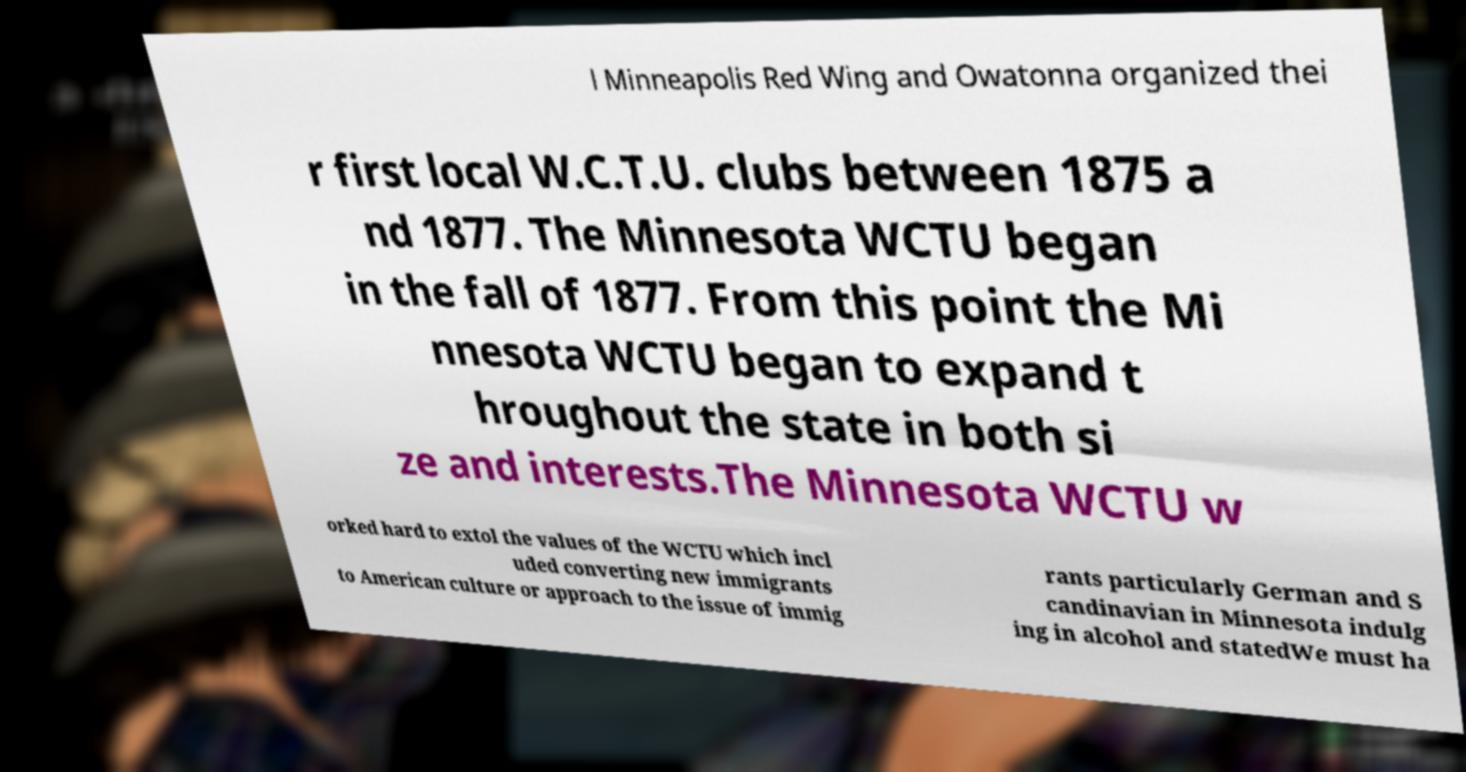I need the written content from this picture converted into text. Can you do that? l Minneapolis Red Wing and Owatonna organized thei r first local W.C.T.U. clubs between 1875 a nd 1877. The Minnesota WCTU began in the fall of 1877. From this point the Mi nnesota WCTU began to expand t hroughout the state in both si ze and interests.The Minnesota WCTU w orked hard to extol the values of the WCTU which incl uded converting new immigrants to American culture or approach to the issue of immig rants particularly German and S candinavian in Minnesota indulg ing in alcohol and statedWe must ha 